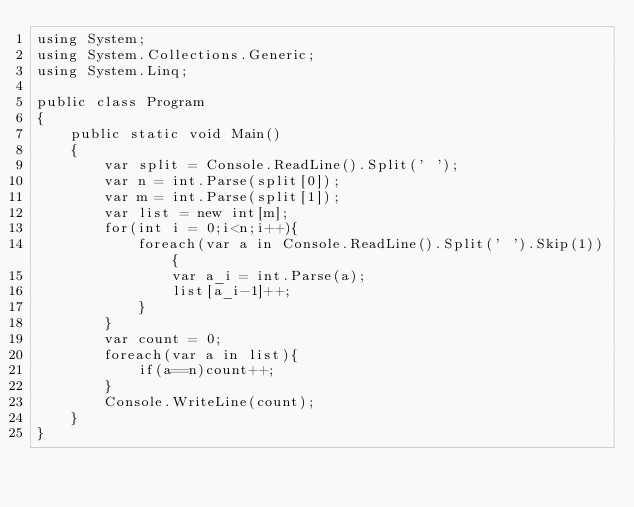<code> <loc_0><loc_0><loc_500><loc_500><_C#_>using System;
using System.Collections.Generic;
using System.Linq;
					
public class Program
{
	public static void Main()
	{
		var split = Console.ReadLine().Split(' ');
		var n = int.Parse(split[0]);
		var m = int.Parse(split[1]);
		var list = new int[m];
		for(int i = 0;i<n;i++){
			foreach(var a in Console.ReadLine().Split(' ').Skip(1)){
				var a_i = int.Parse(a);
				list[a_i-1]++;
			}
		}
		var count = 0;
		foreach(var a in list){
			if(a==n)count++;
		}
		Console.WriteLine(count);
	}
}</code> 